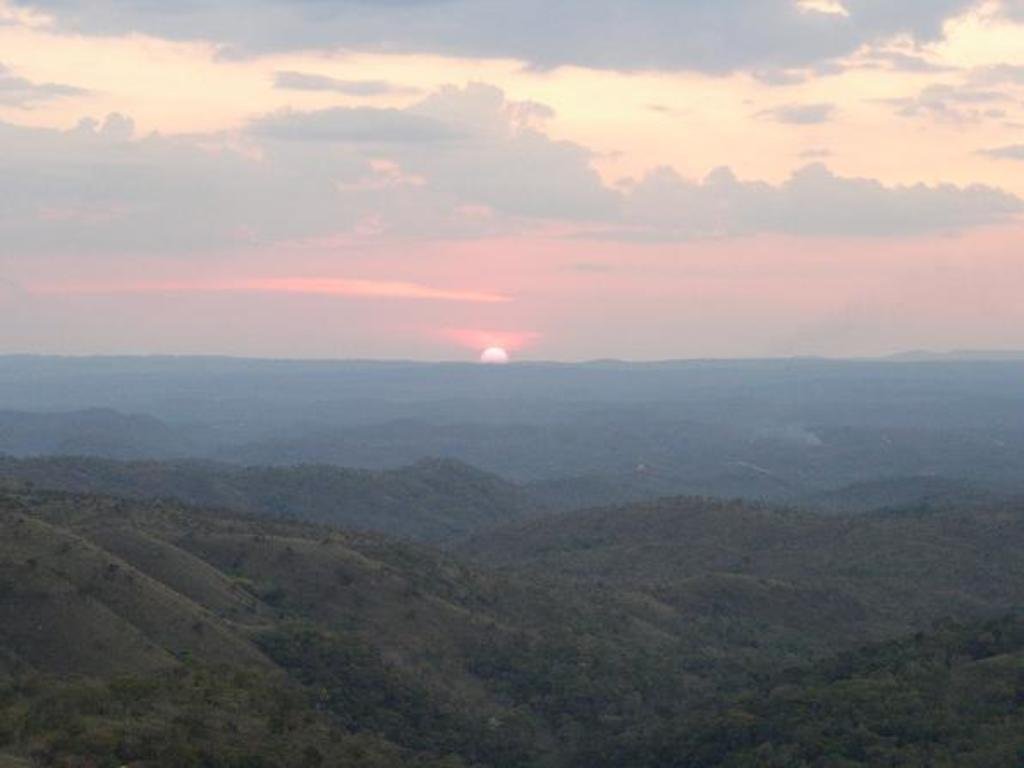What type of landscape can be seen in the image? There are hills in the image. What other natural elements are present in the image? There are trees in the image. What is visible in the background of the image? The sky is visible in the background of the image. What can be observed in the sky? Clouds are present in the sky. What type of plot is being prepared for dinner in the image? There is no plot or dinner preparation visible in the image; it features hills, trees, and a sky with clouds. What kind of bottle can be seen on the hill in the image? There is no bottle present on the hill in the image. 